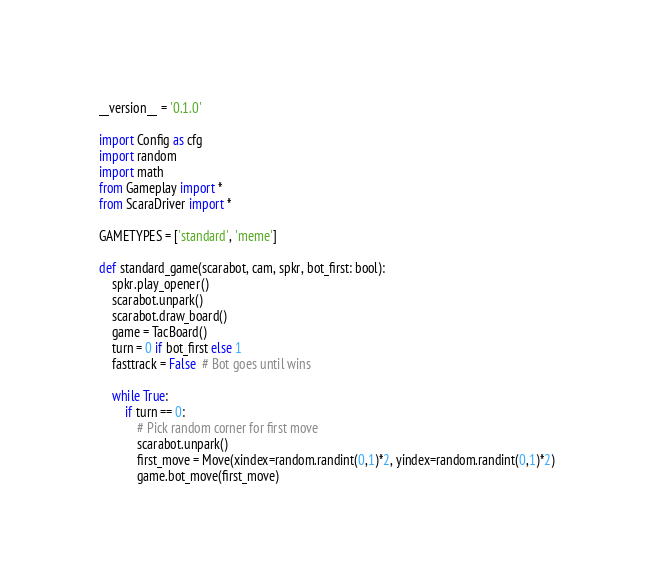Convert code to text. <code><loc_0><loc_0><loc_500><loc_500><_Python_>__version__ = '0.1.0'

import Config as cfg
import random
import math
from Gameplay import *
from ScaraDriver import *

GAMETYPES = ['standard', 'meme']

def standard_game(scarabot, cam, spkr, bot_first: bool):
    spkr.play_opener()
    scarabot.unpark()
    scarabot.draw_board()
    game = TacBoard()
    turn = 0 if bot_first else 1
    fasttrack = False  # Bot goes until wins

    while True:
        if turn == 0:
            # Pick random corner for first move
            scarabot.unpark()
            first_move = Move(xindex=random.randint(0,1)*2, yindex=random.randint(0,1)*2)
            game.bot_move(first_move)</code> 